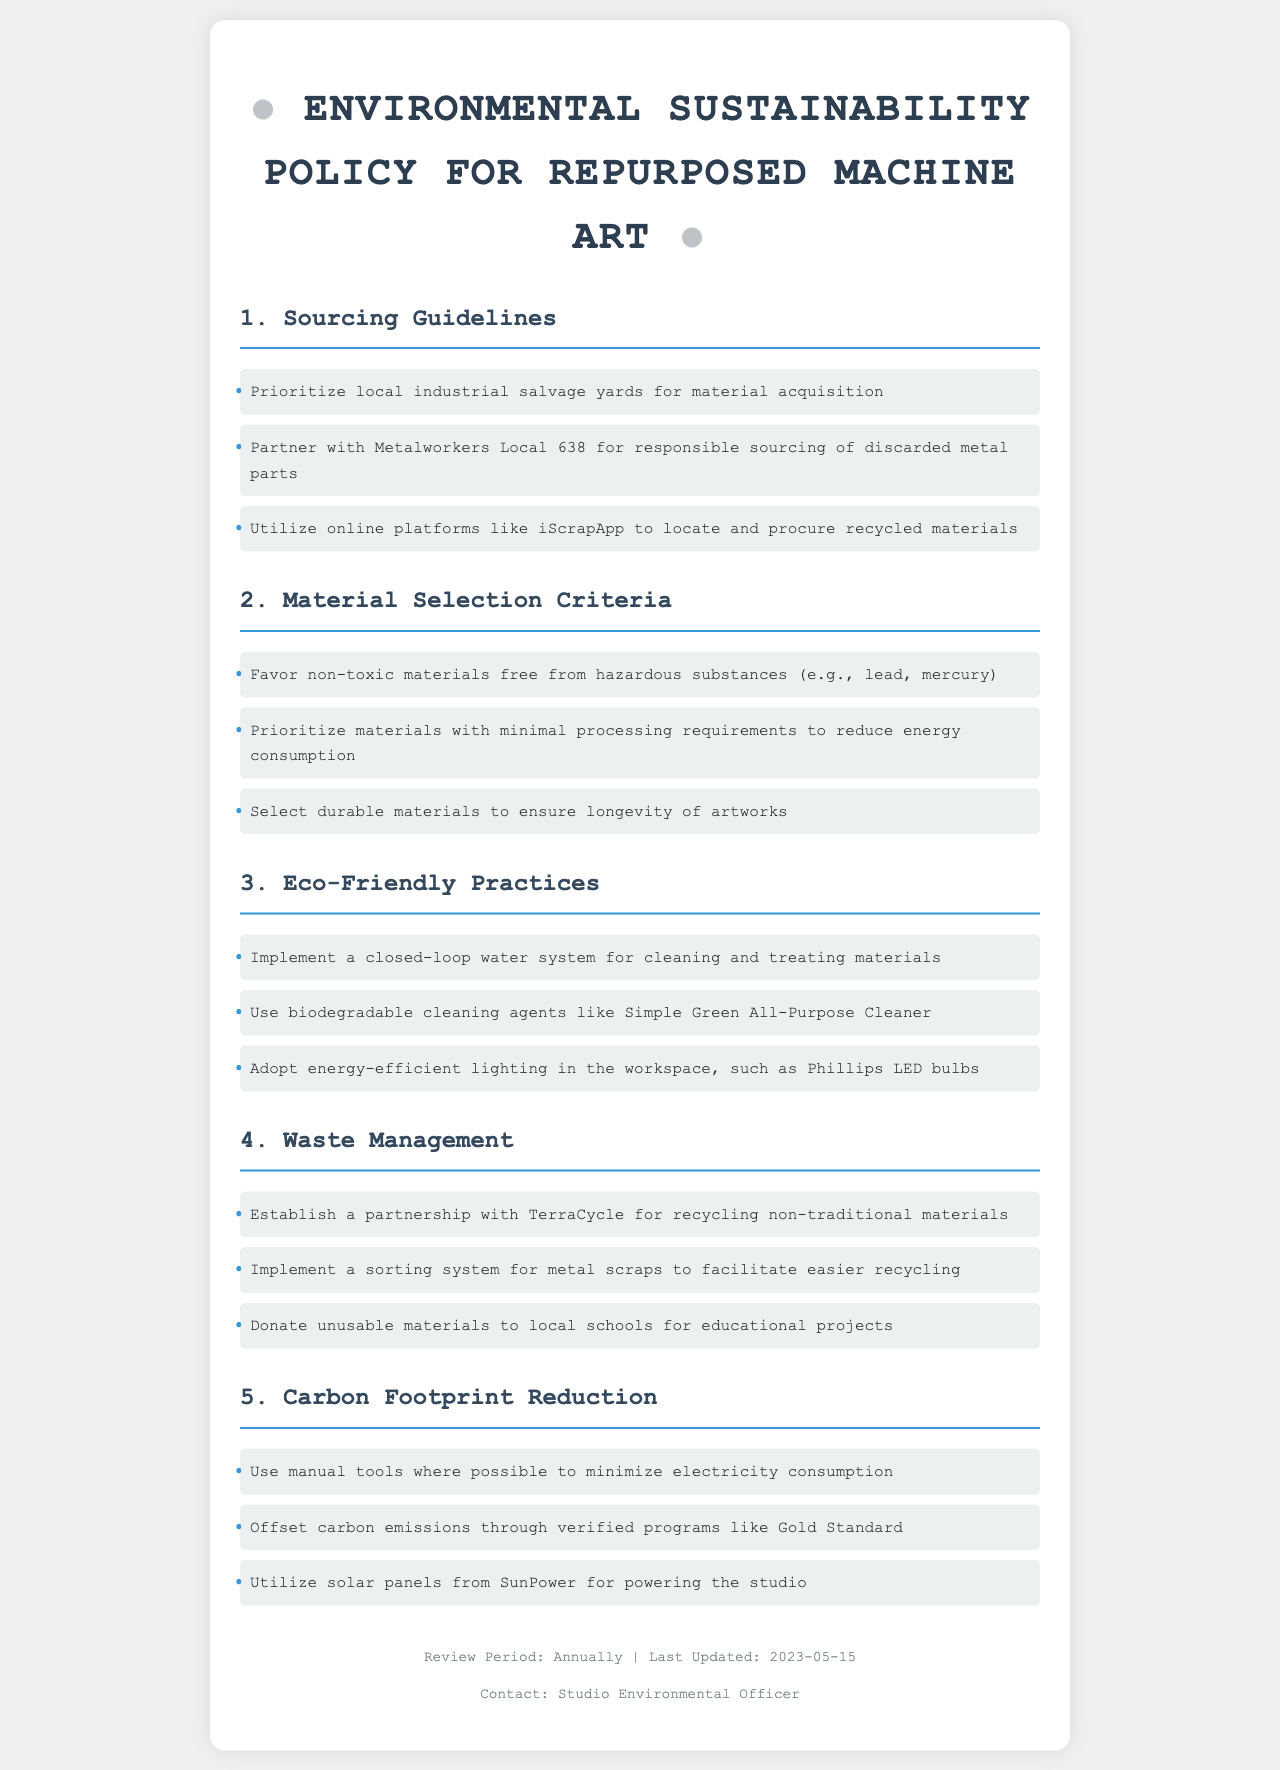What are the sourcing guidelines? The sourcing guidelines include prioritizing local industrial salvage yards, partnering with Metalworkers Local 638, and utilizing online platforms like iScrapApp.
Answer: Local industrial salvage yards, Metalworkers Local 638, iScrapApp What is a key criterion for material selection? One key criterion for material selection is that materials should be non-toxic and free from hazardous substances.
Answer: Non-toxic materials What waste management partnership is mentioned? The document mentions a partnership with TerraCycle for recycling non-traditional materials.
Answer: TerraCycle What eco-friendly cleaning agent is recommended? The recommended eco-friendly cleaning agent is Simple Green All-Purpose Cleaner.
Answer: Simple Green All-Purpose Cleaner How often should the policy be reviewed? The policy should be reviewed annually.
Answer: Annually What is a method suggested for carbon footprint reduction? A suggested method for carbon footprint reduction is using manual tools to minimize electricity consumption.
Answer: Manual tools 